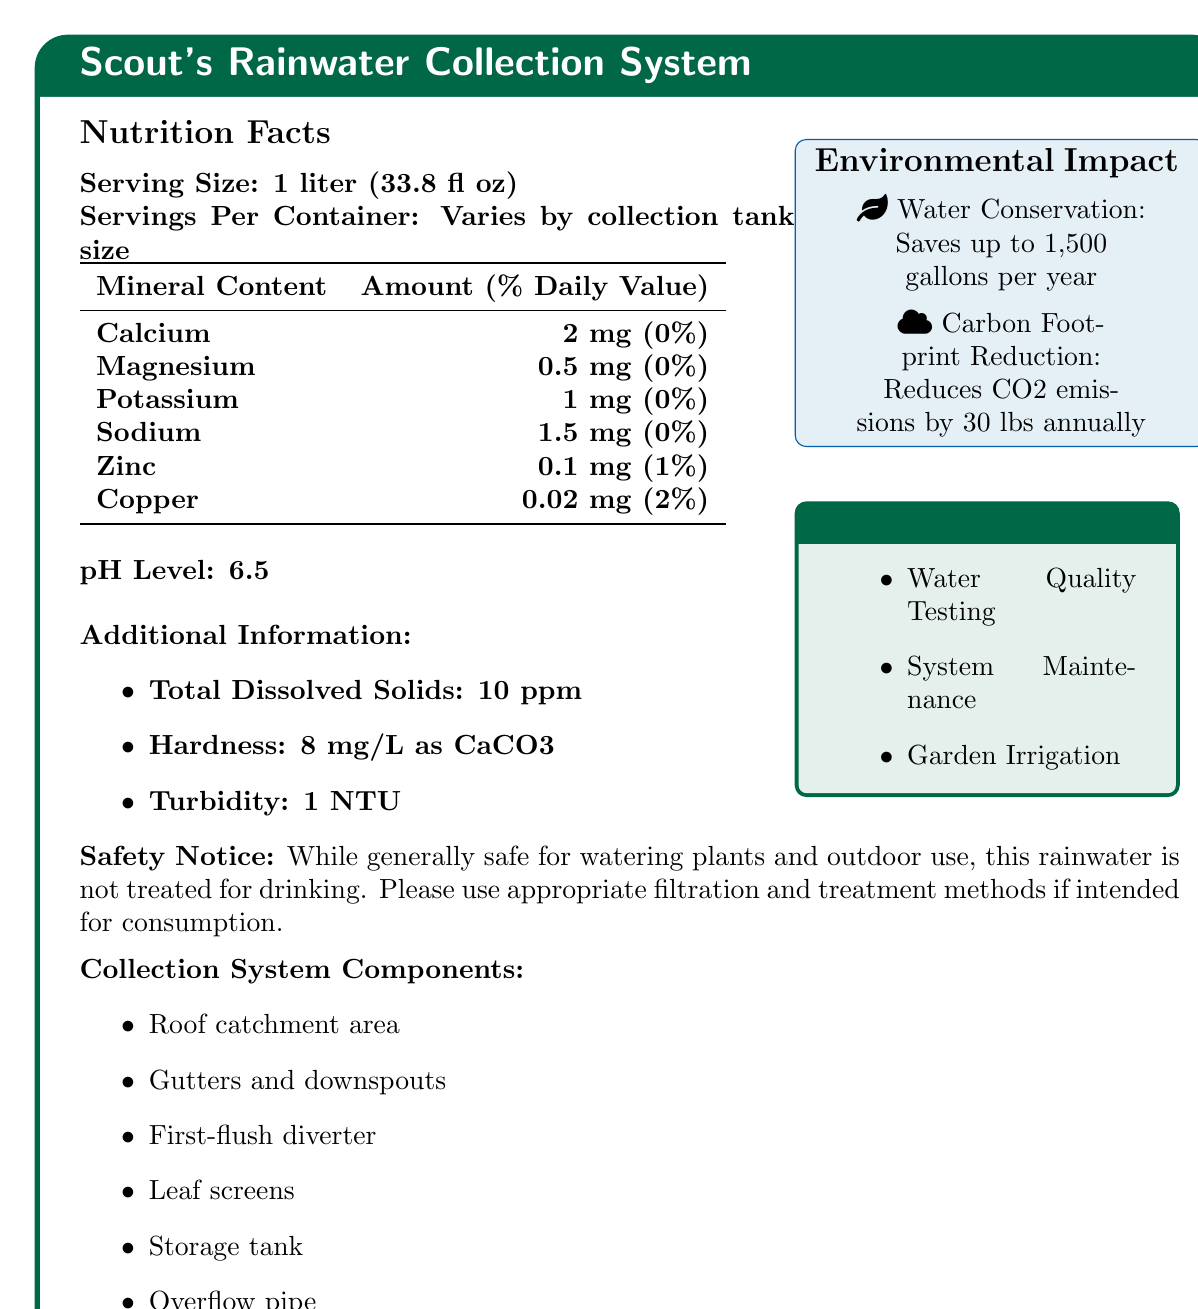what is the serving size? The document specifies that the serving size is 1 liter (33.8 fl oz).
Answer: 1 liter (33.8 fl oz) what is the pH level of the rainwater collected? The document notes that the pH level of the rainwater collected using the system is 6.5.
Answer: 6.5 how much zinc is in a serving, and what is its daily value percentage? According to the mineral content data, one serving contains 0.1 mg of zinc, which is 1% of the daily value.
Answer: 0.1 mg, 1% what is the total hardness of the water in mg/L as CaCO3? The document lists the total hardness of the water as 8 mg/L as CaCO3 under additional information.
Answer: 8 mg/L what scout activities can be done with the rainwater collection system? The document mentions three scout activities: Water Quality Testing, System Maintenance, and Garden Irrigation.
Answer: Water Quality Testing, System Maintenance, Garden Irrigation how much calcium is in one serving? A. 2 mg B. 1 mg C. 0.5 mg D. 1.5 mg The document states that there are 2 mg of calcium in one serving.
Answer: A. 2 mg what is the percentage of daily value for copper in the rainwater? A. 0% B. 1% C. 2% D. 5% The document specifies that the daily value for copper is 2%.
Answer: C. 2% is the collected rainwater safe for drinking? The document explicitly states that the rainwater is not treated for drinking and should be filtered and treated if intended for consumption.
Answer: No summarize the main purposes and components of the Scout's Rainwater Collection System. The document details the nutritional composition, pH levels, and several environmental and educational benefits of the rainwater collection system. It also provides a list of its main components.
Answer: The Scout's Rainwater Collection System is designed to collect rainwater for gardening and environmental stewardship activities. It emphasizes water conservation and carbon footprint reduction while providing educational activities related to water quality testing and maintenance. Key components include a roof catchment area, gutters and downspouts, a first-flush diverter, leaf screens, a storage tank, and an overflow pipe. what is the reduction in CO2 emissions per year due to using the rainwater collection system? Under the environmental impact section, the document mentions that the system reduces CO2 emissions by 30 lbs annually.
Answer: 30 lbs annually how many servings are in one container of collected rainwater? The document states that the number of servings per container varies by collection tank size, so the exact number cannot be determined from the information given.
Answer: Cannot be determined 